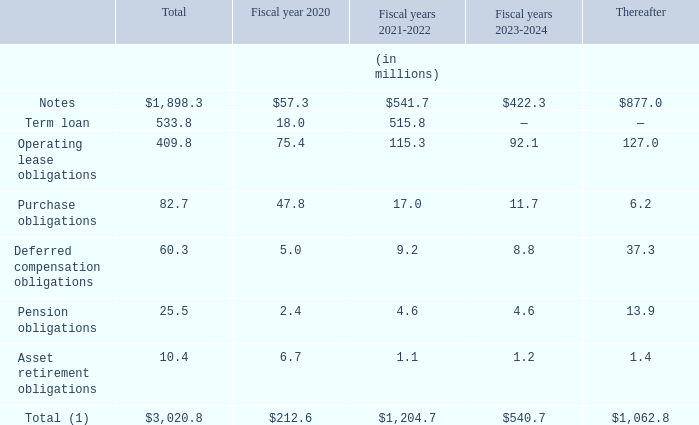CONTRACTUAL OBLIGATIONS
The following table summarizes our significant financial contractual obligations at January 31, 2019, and the effect such obligations are expected to have on our liquidity and cash flows in future periods.
(1) This table generally excludes amounts already recorded on the balance sheet as current liabilities, certain purchase obligations as discussed below, long term deferred revenue, and amounts related to income tax liabilities for uncertain tax positions, since we cannot predict with reasonable reliability the timing of cash settlements to the respective taxing authorities (see Part II, Item 8, Note 5, “Income Taxes” in the Notes to Consolidated Financial Statements).
Notes consist of the Notes issued in December 2012, June 2015 and June 2017. See Part II, Item 8, Note 8, "Borrowing Arrangements," in the Notes to Consolidated Financial Statements for further discussion..
Term loan consists of the Term Loan Agreement entered into on December 17, 2018 as described above.
Operating lease obligations consist primarily of obligations for facilities, net of sublease income, computer equipment and other equipment leases
Purchase obligations are contractual obligations for purchase of goods or services and are defined as agreements that are enforceable and legally binding on Autodesk and that specify all significant terms, including: fixed or minimum quantities to be purchased; fixed, minimum, or variable price provisions; and the approximate timing of the transaction. Purchase obligations relate primarily to enterprise subscription agreements, IT infrastructure costs, and marketing costs
Deferred compensation obligations relate to amounts held in a rabbi trust under our non-qualified deferred compensation plan. See Part II, Item 8, Note 7, “Deferred Compensation,” in our Notes to Consolidated Financial Statements for further information regarding this plan.
Pension obligations relate to our obligations for pension plans outside of the U.S. See Part II, Item 8, Note 15, “Retirement Benefit Plans,” in our Notes to Consolidated Financial Statements for further information regarding these obligations.
Asset retirement obligations represent the estimated costs to bring certain office buildings that we lease back to their original condition after the termination of the lease
Purchase orders or contracts for the purchase of supplies and other goods and services are not included in the table above. We are not able to determine the aggregate amount of such purchase orders that represent contractual obligations, as purchase orders may represent authorizations to purchase rather than binding agreements. Our purchase orders are based on our current procurement or development needs and are fulfilled by our vendors within short time horizons. We do not have significant agreements for the purchase of supplies or other goods specifying minimum quantities or set prices that exceed our expected requirements for three months. In addition, we have certain software royalty commitments associated with the shipment and licensing of certain products.
The expected timing of payment of the obligations discussed above is estimated based on current information. Timing of payments and actual amounts paid may be different depending on the time of receipt of goods or services or changes to agreed upon amounts for some obligations.
We provide indemnifications of varying scopes and certain guarantees, including limited product warranties. Historically, costs related to these warranties and indemnifications have not been significant, but because potential future costs are highly variable, we are unable to estimate the maximum potential impact of these guarantees on our future results of operations
What are purchase obligations? Purchase obligations are contractual obligations for purchase of goods or services and are defined as agreements that are enforceable and legally binding on autodesk and that specify all significant terms, including: fixed or minimum quantities to be purchased; fixed, minimum, or variable price provisions; and the approximate timing of the transaction. Why are the purchase of supplies and other goods and services are not included in the table? We are not able to determine the aggregate amount of such purchase orders that represent contractual obligations, as purchase orders may represent authorizations to purchase rather than binding agreements. our purchase orders are based on our current procurement or development needs and are fulfilled by our vendors within short time horizons. What was the pension obligation for the fiscal year 2020? 2.4. What is the amount of notes for fiscal years 2021-2024?
Answer scale should be: million. 541.7+422.3 
Answer: 964. What is the percentage of purchase obligations out of total obligations in 2020?
Answer scale should be: percent. (47.8/212.6)
Answer: 22.48. How much does contractual obligations from 2024 thereafter account for the total contractual obligations?
Answer scale should be: percent. 1,062.8/3,020.8 
Answer: 35.18. 